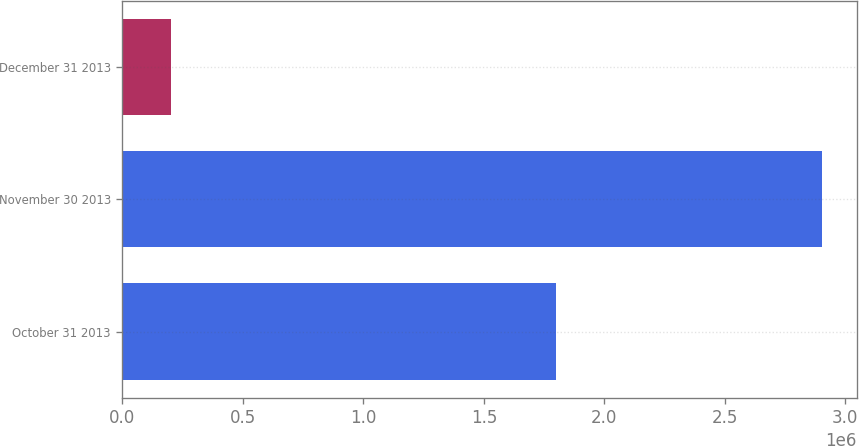Convert chart to OTSL. <chart><loc_0><loc_0><loc_500><loc_500><bar_chart><fcel>October 31 2013<fcel>November 30 2013<fcel>December 31 2013<nl><fcel>1.8e+06<fcel>2.903e+06<fcel>200000<nl></chart> 